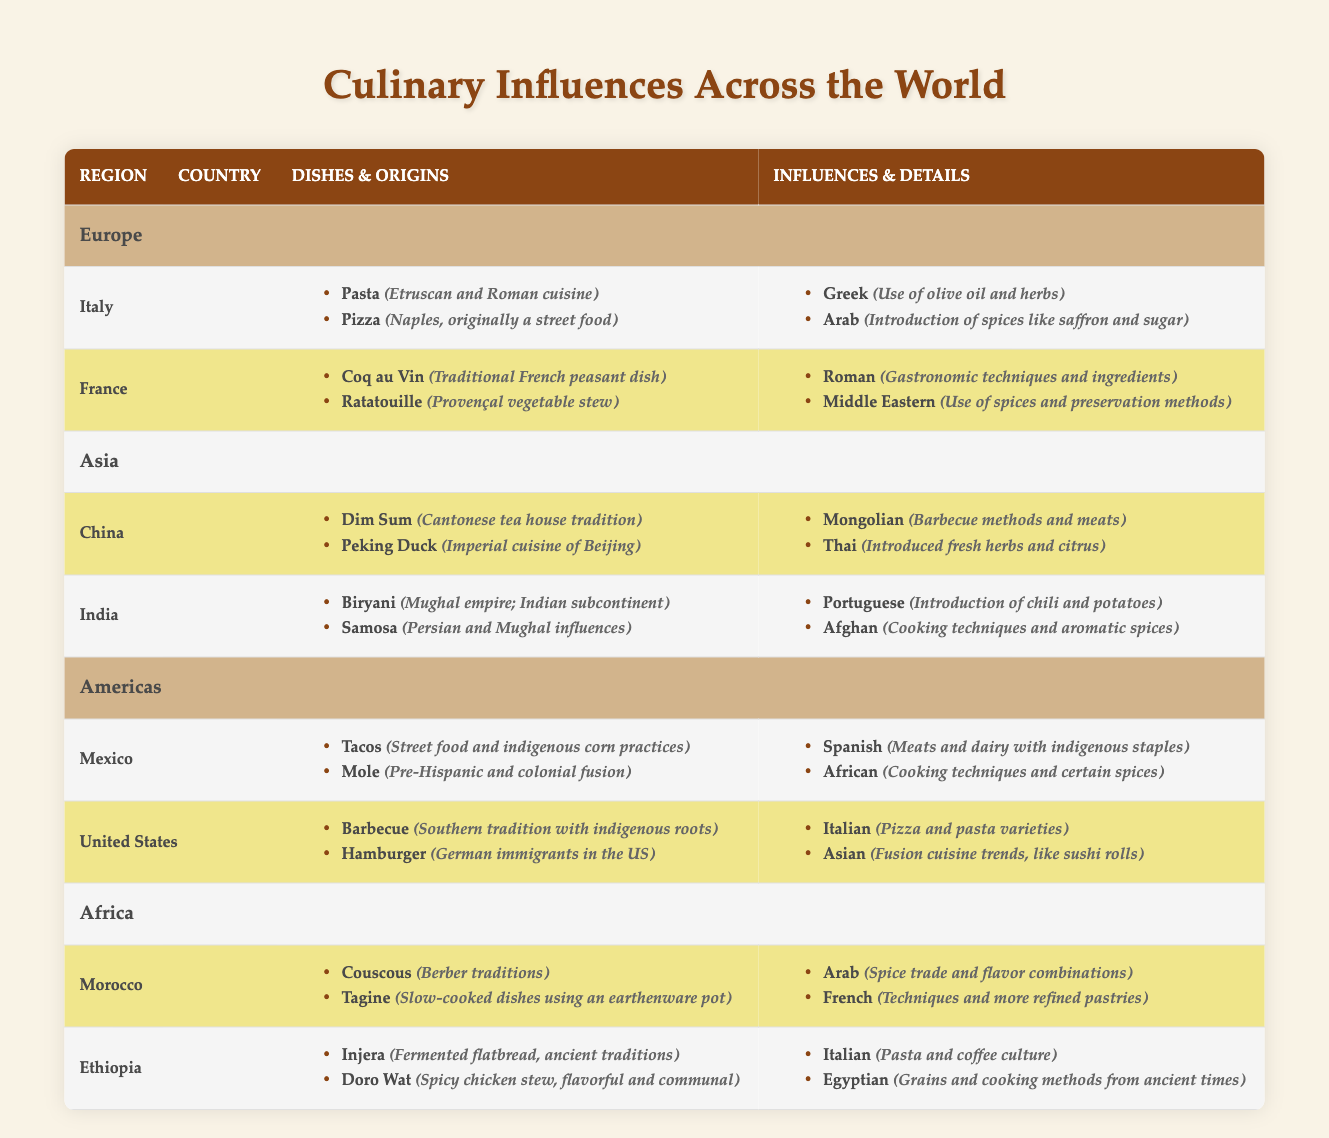What's the origin of Pasta? In the Italy section, under the Dishes for Pasta, it mentions that its origin is Etruscan and Roman cuisine.
Answer: Etruscan and Roman cuisine Which dish is associated with Imperial cuisine in China? In the China section, it lists Peking Duck under the Dishes, indicating that it is associated with Imperial cuisine of Beijing.
Answer: Peking Duck How many types of influences does India have listed in the table? In the India section, there are two influences noted: Portuguese and Afghan, which can be counted directly from the list provided.
Answer: 2 Does Morocco have a dish called Couscous? Yes, in the Morocco section, Couscous is listed as one of the dishes along with its origin, which is stated as Berber traditions.
Answer: Yes Which country has the dish Samosa, and what are its influences? Samosa is listed in the India section with influences from Portuguese (chili and potatoes) and Afghan (cooking techniques and spices). This requires knowing the origin of Samosa as well as the associated influences.
Answer: India: Portuguese and Afghan 